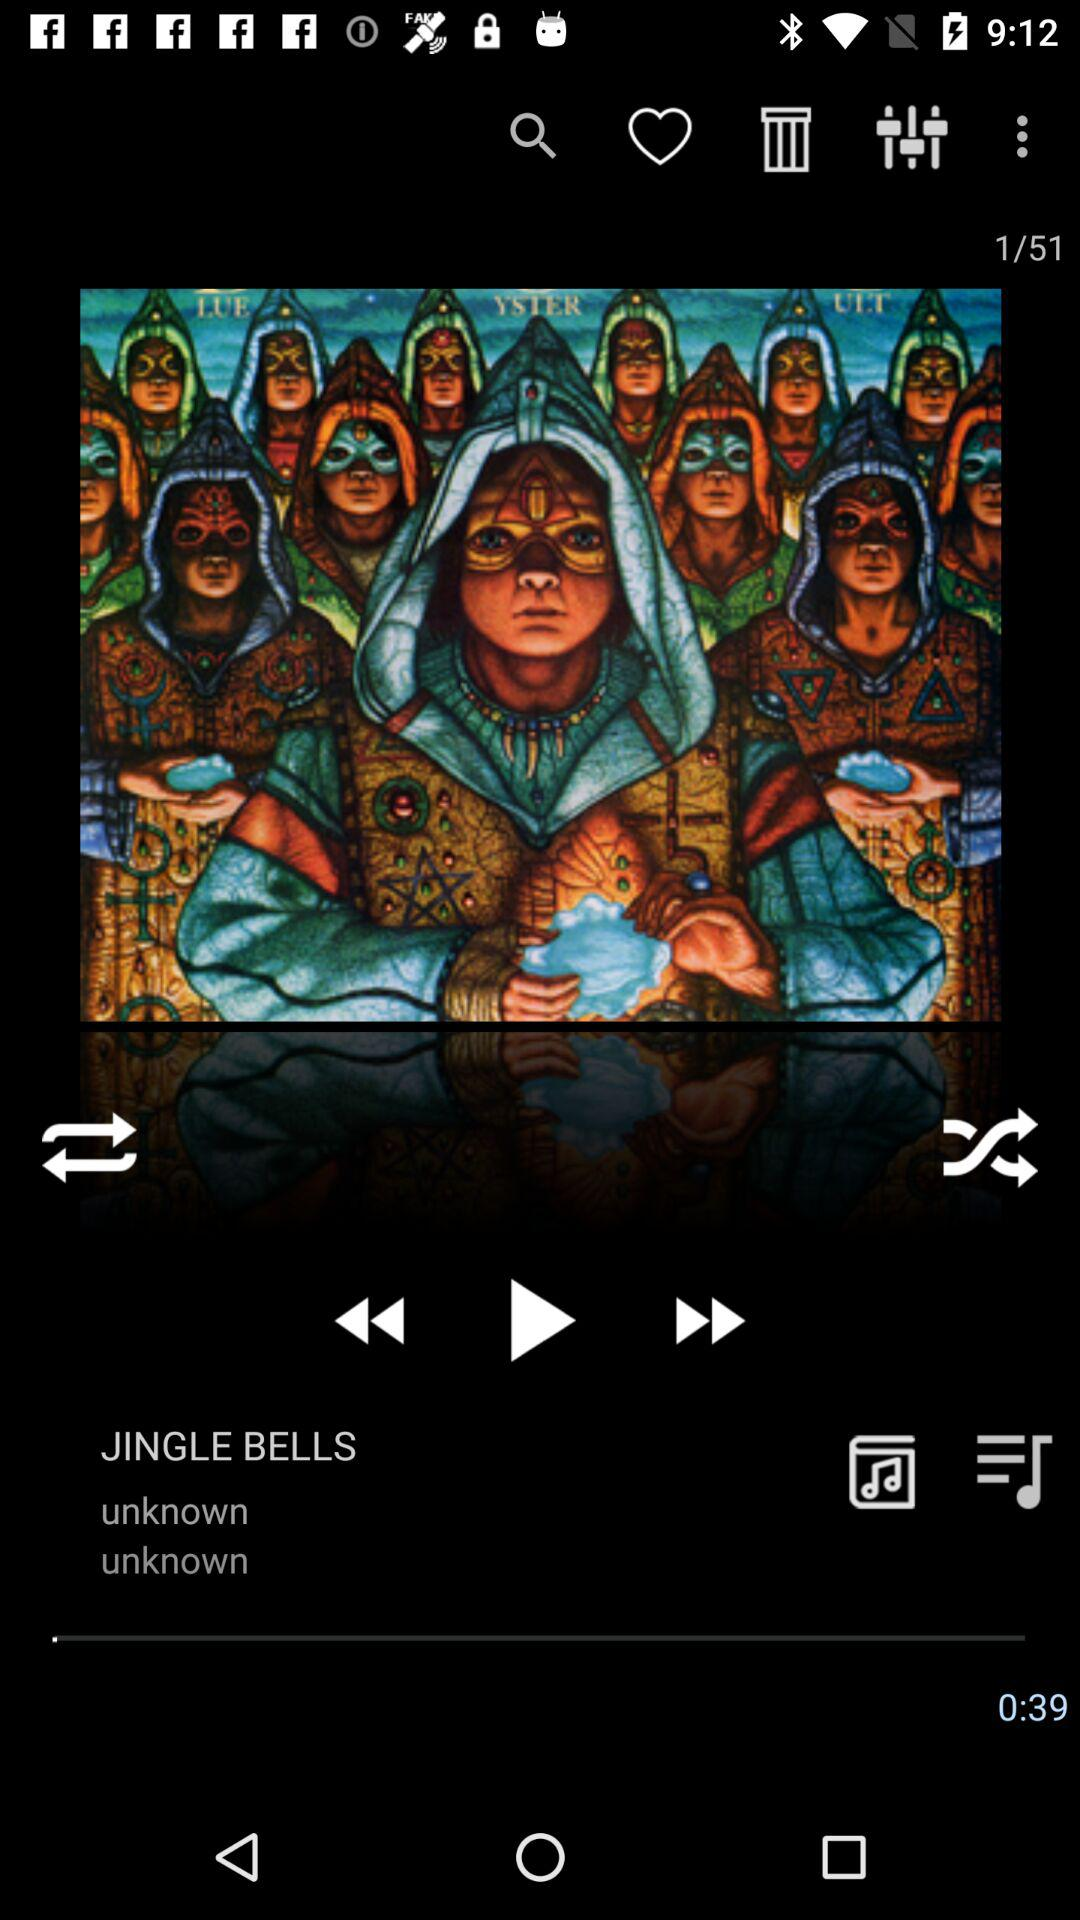What is the time duration? The time duration is 39 seconds. 